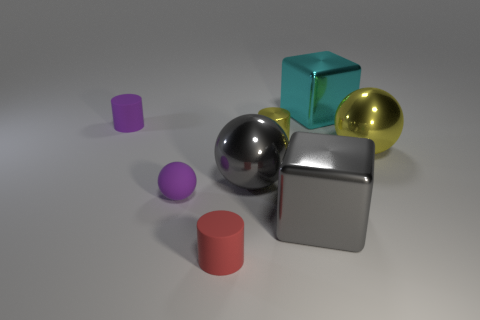Subtract all matte cylinders. How many cylinders are left? 1 Subtract 1 spheres. How many spheres are left? 2 Add 1 large red shiny things. How many objects exist? 9 Subtract 1 cyan blocks. How many objects are left? 7 Subtract all cubes. How many objects are left? 6 Subtract all big objects. Subtract all cyan things. How many objects are left? 3 Add 6 large gray cubes. How many large gray cubes are left? 7 Add 2 red rubber cylinders. How many red rubber cylinders exist? 3 